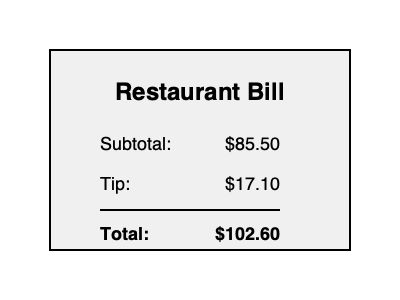After enjoying a delightful meal at your favorite local restaurant, you receive the bill shown above. As a frequent diner and someone who often recommends this establishment to colleagues, you want to ensure you're tipping appropriately. What is the tip percentage you've given based on the subtotal of the bill? To calculate the tip percentage, we'll follow these steps:

1. Identify the given information:
   - Subtotal: $85.50
   - Tip amount: $17.10

2. Set up the equation for calculating tip percentage:
   $\text{Tip Percentage} = \frac{\text{Tip Amount}}{\text{Subtotal}} \times 100\%$

3. Plug in the values:
   $\text{Tip Percentage} = \frac{\$17.10}{\$85.50} \times 100\%$

4. Perform the division:
   $\text{Tip Percentage} = 0.2 \times 100\%$

5. Convert the decimal to a percentage:
   $\text{Tip Percentage} = 20\%$

Therefore, the tip percentage given is 20% of the subtotal.
Answer: 20% 